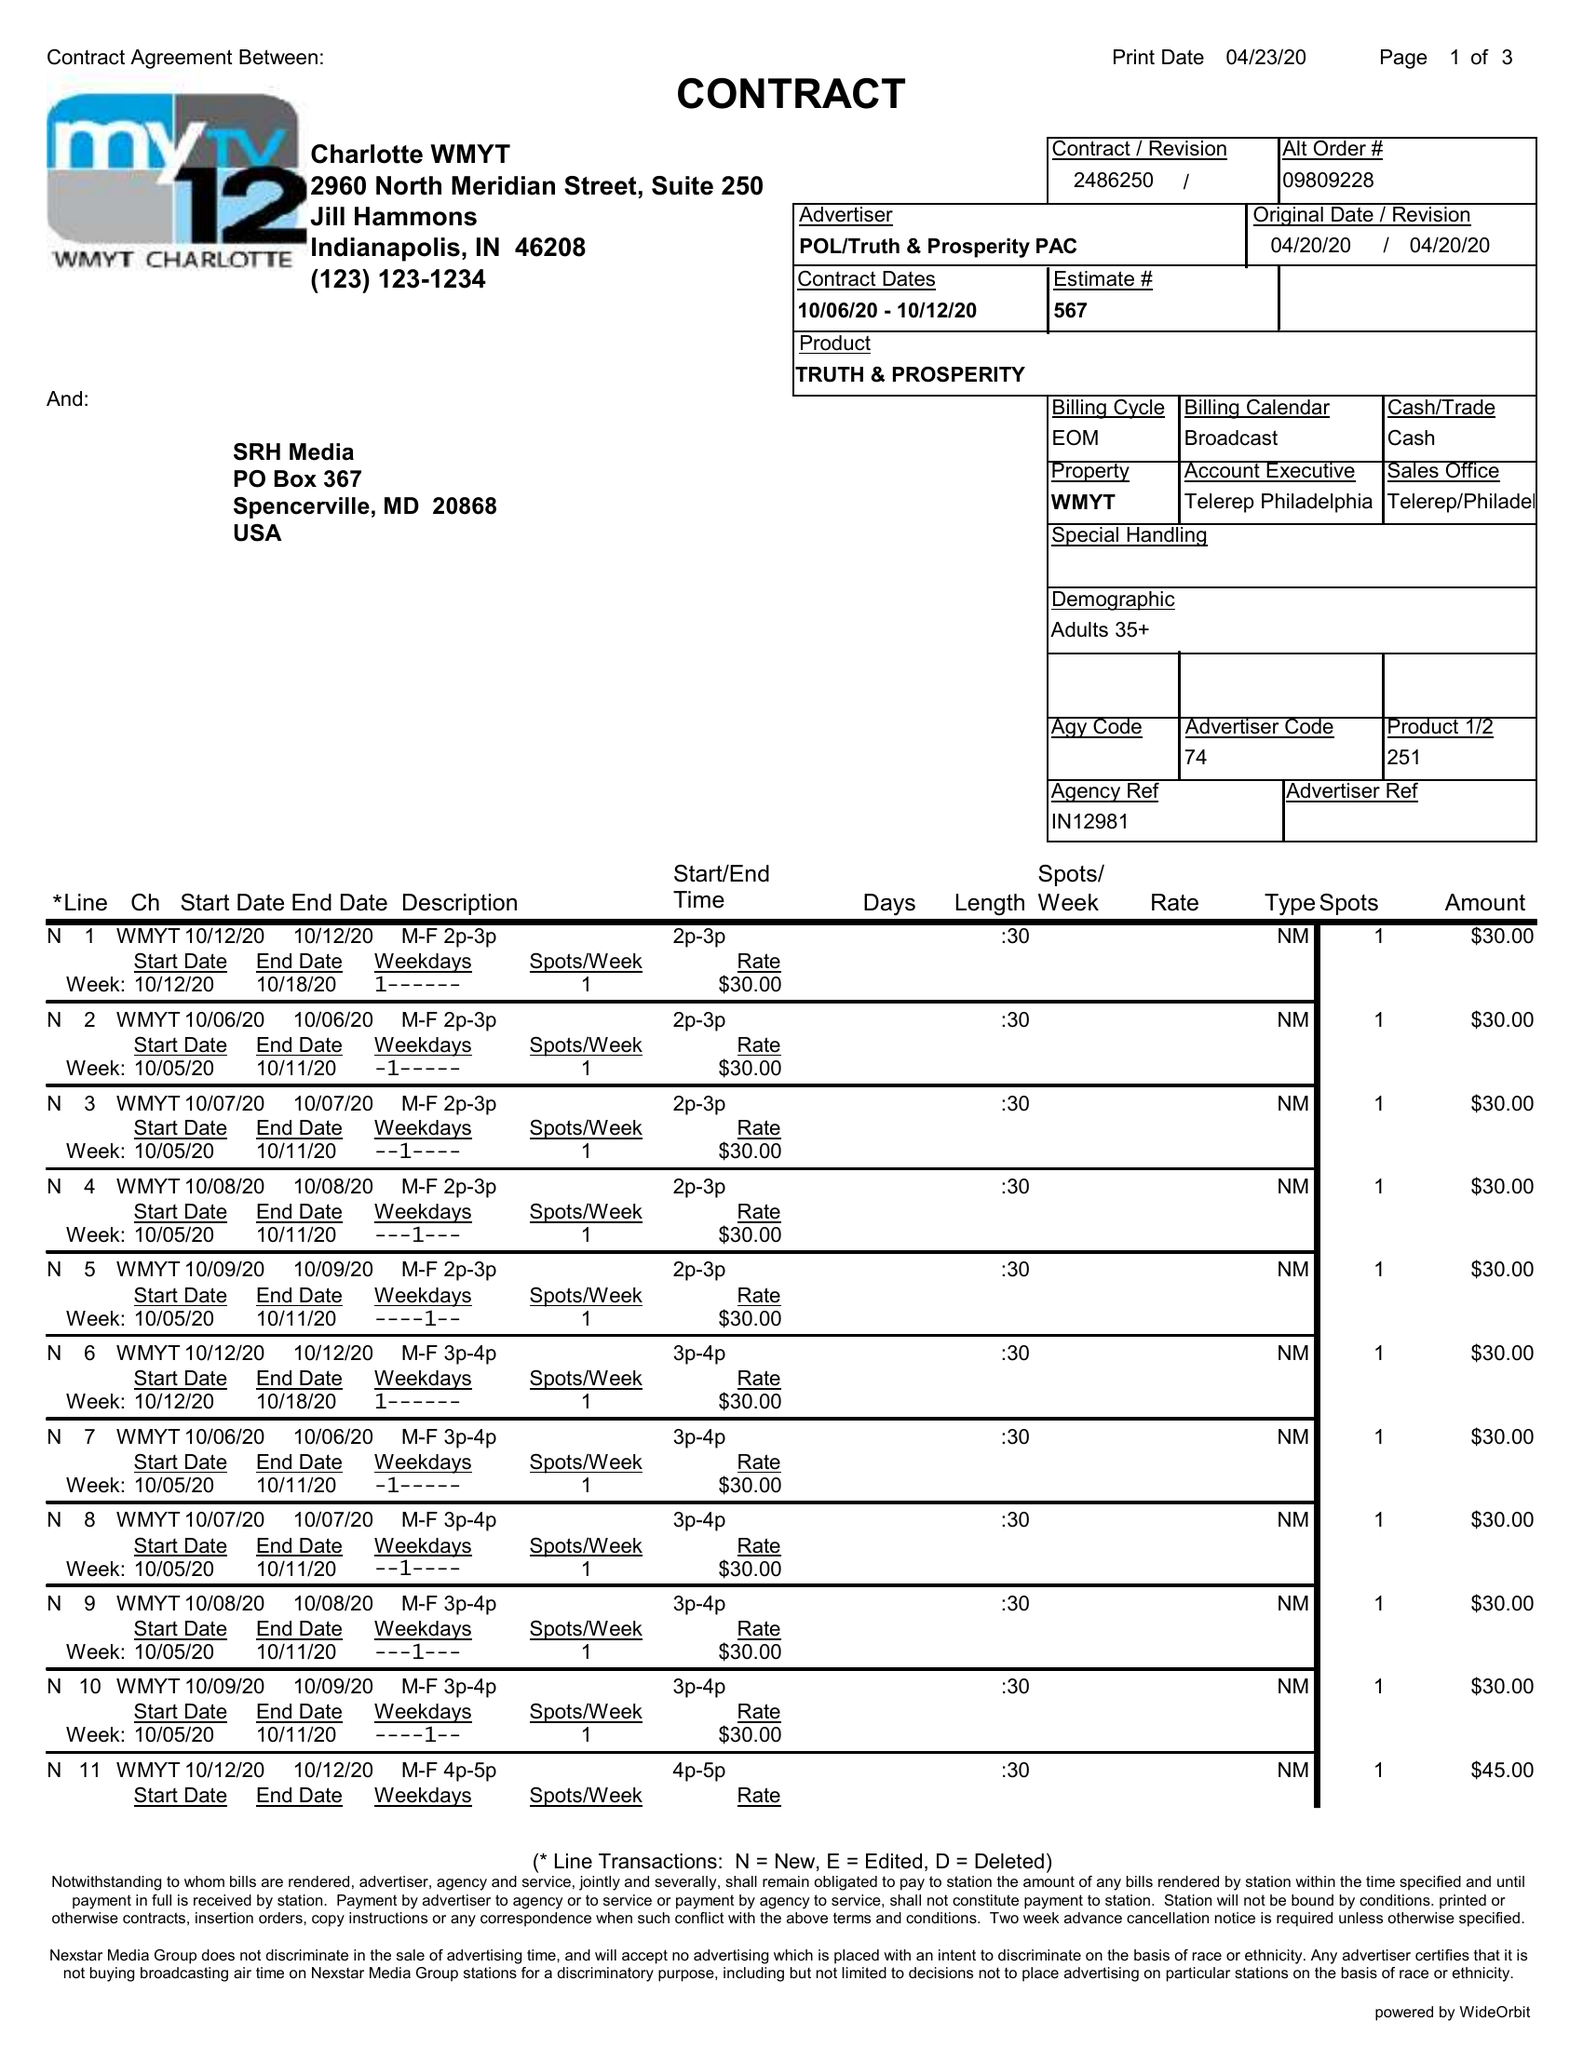What is the value for the flight_to?
Answer the question using a single word or phrase. 10/12/20 